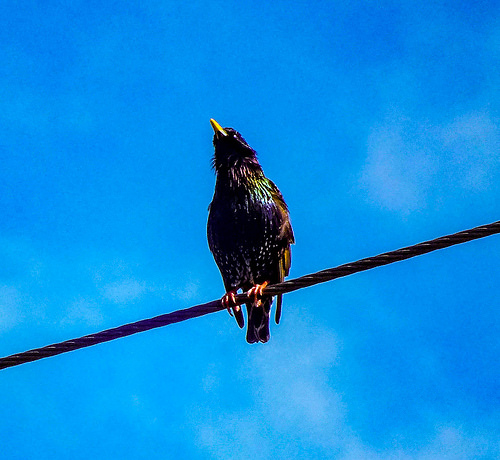<image>
Can you confirm if the bird is on the sky? No. The bird is not positioned on the sky. They may be near each other, but the bird is not supported by or resting on top of the sky. Is the bird next to the sky? No. The bird is not positioned next to the sky. They are located in different areas of the scene. 